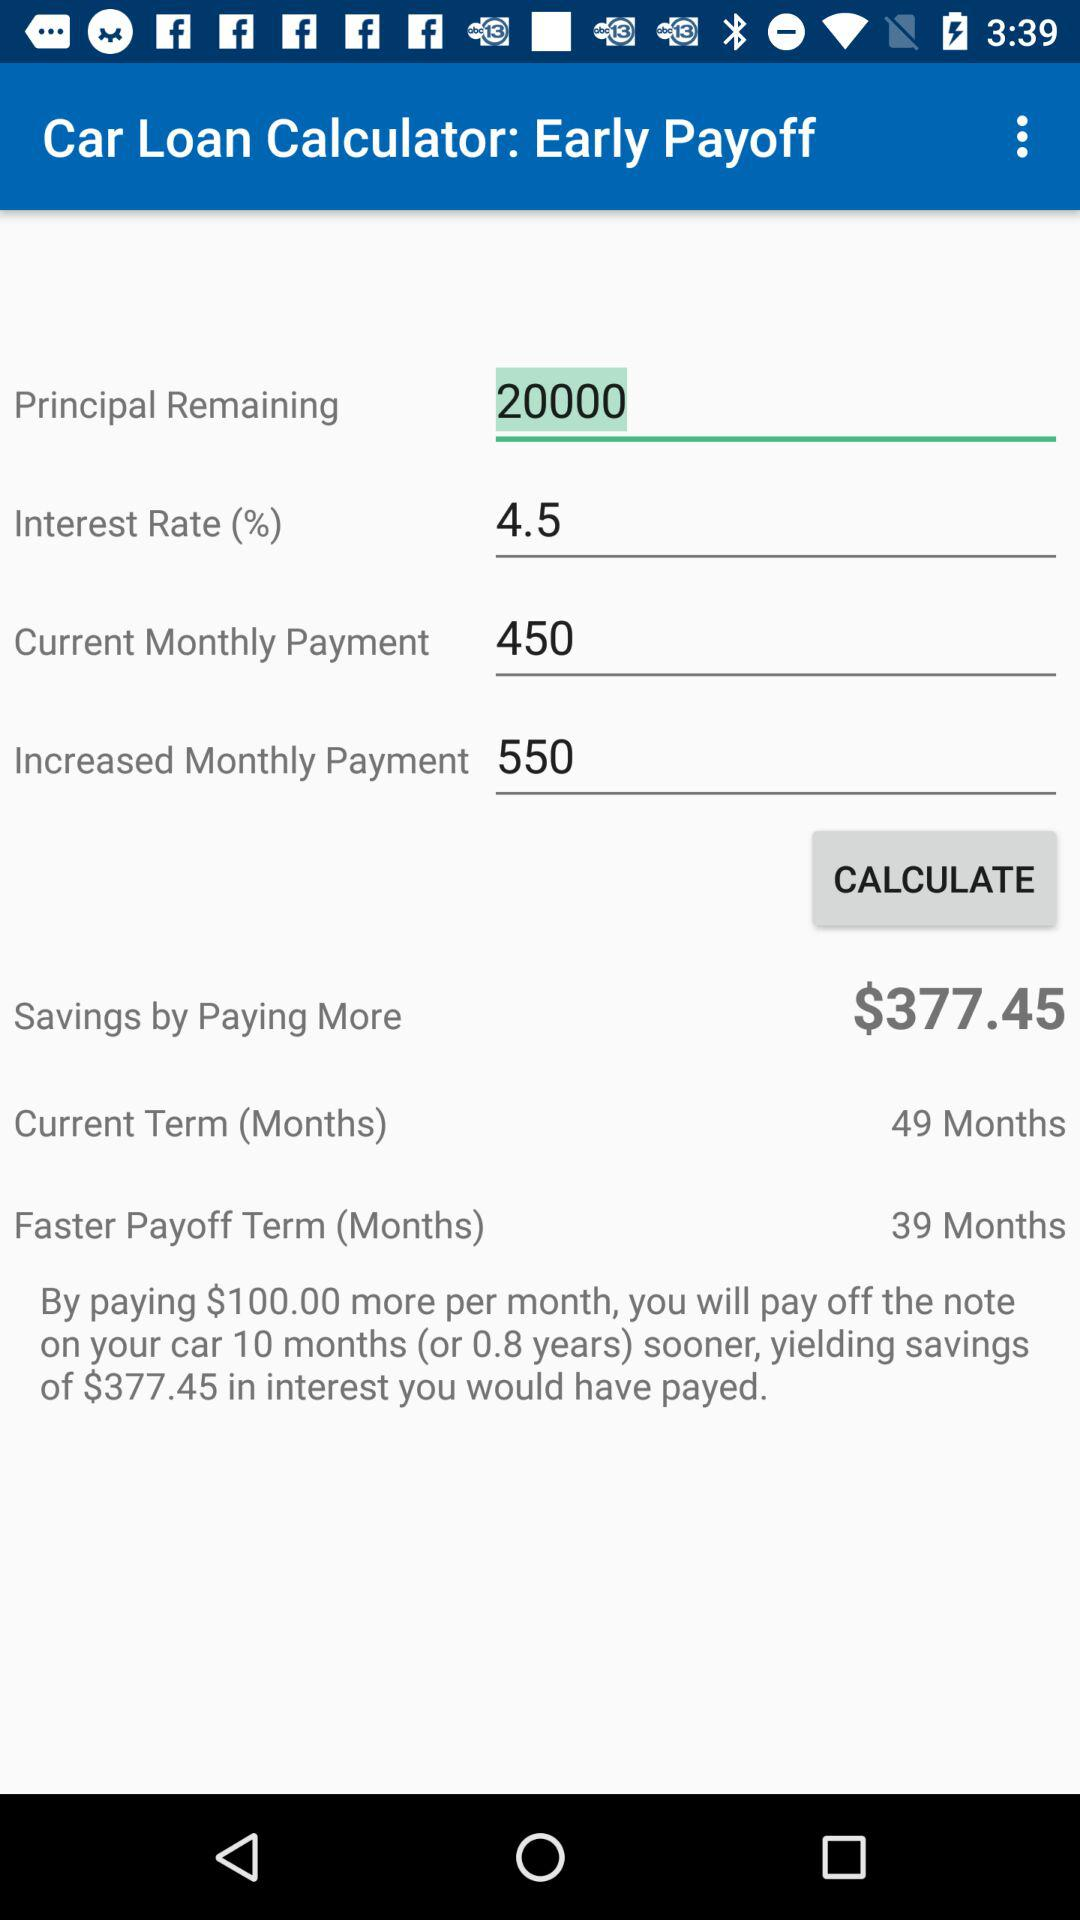What is the current term? The current term is 49 months. 